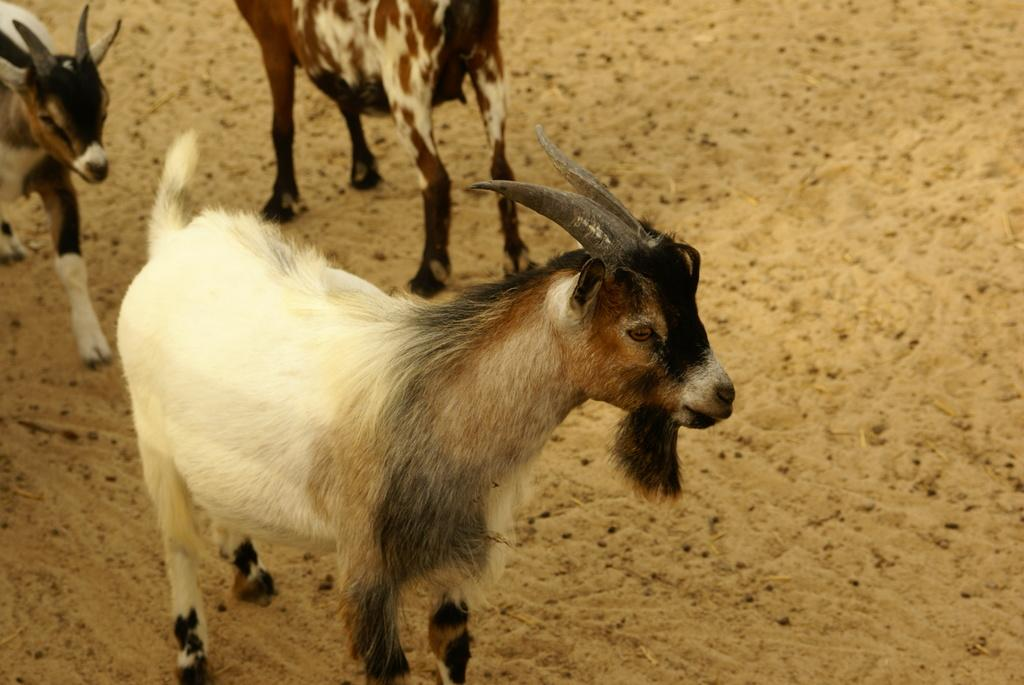What types of living organisms can be seen in the image? There are animals in the image. What type of terrain is visible at the bottom of the image? There is sand visible at the bottom of the image. What type of throne can be seen in the image? There is no throne present in the image. Is it raining in the image? The provided facts do not mention any rain, so we cannot determine if it is raining in the image. 